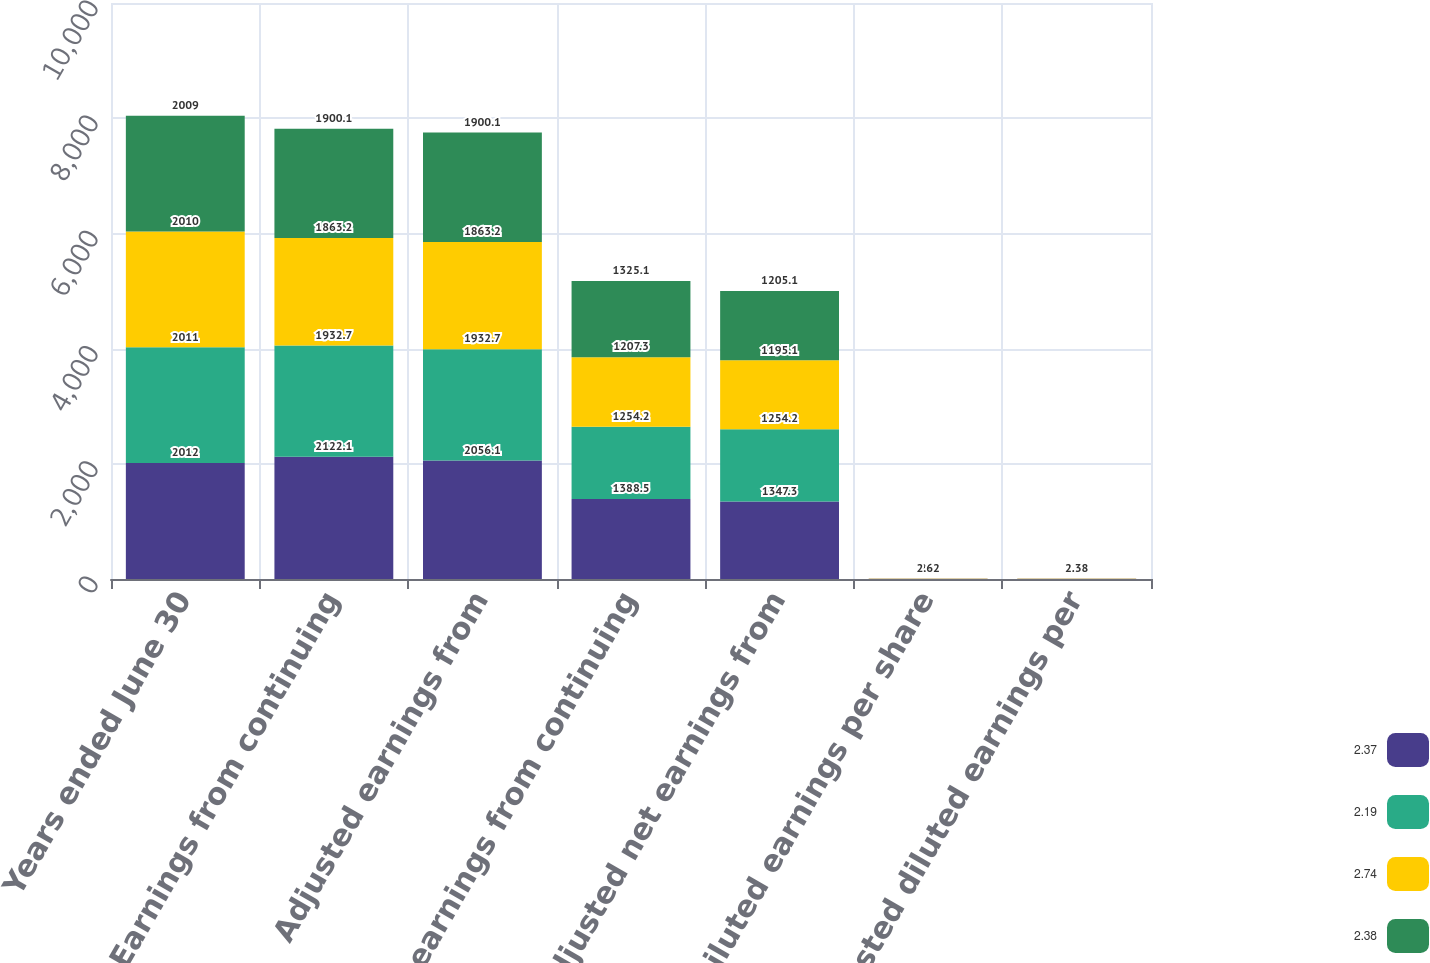Convert chart to OTSL. <chart><loc_0><loc_0><loc_500><loc_500><stacked_bar_chart><ecel><fcel>Years ended June 30<fcel>Earnings from continuing<fcel>Adjusted earnings from<fcel>Net earnings from continuing<fcel>Adjusted net earnings from<fcel>Diluted earnings per share<fcel>Adjusted diluted earnings per<nl><fcel>2.37<fcel>2012<fcel>2122.1<fcel>2056.1<fcel>1388.5<fcel>1347.3<fcel>2.82<fcel>2.74<nl><fcel>2.19<fcel>2011<fcel>1932.7<fcel>1932.7<fcel>1254.2<fcel>1254.2<fcel>2.52<fcel>2.52<nl><fcel>2.74<fcel>2010<fcel>1863.2<fcel>1863.2<fcel>1207.3<fcel>1195.1<fcel>2.4<fcel>2.37<nl><fcel>2.38<fcel>2009<fcel>1900.1<fcel>1900.1<fcel>1325.1<fcel>1205.1<fcel>2.62<fcel>2.38<nl></chart> 